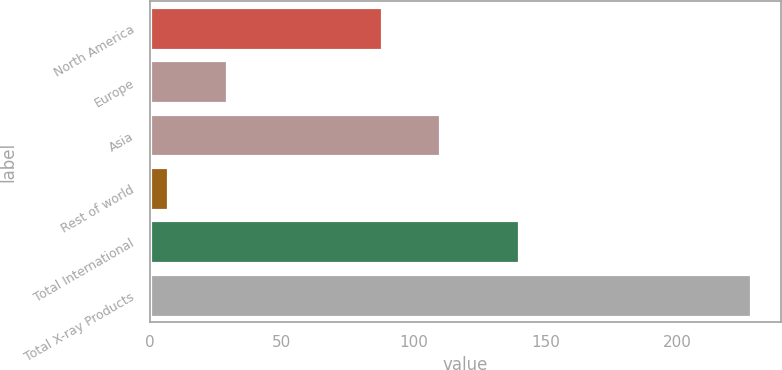Convert chart. <chart><loc_0><loc_0><loc_500><loc_500><bar_chart><fcel>North America<fcel>Europe<fcel>Asia<fcel>Rest of world<fcel>Total International<fcel>Total X-ray Products<nl><fcel>88<fcel>29.1<fcel>110.1<fcel>7<fcel>140<fcel>228<nl></chart> 